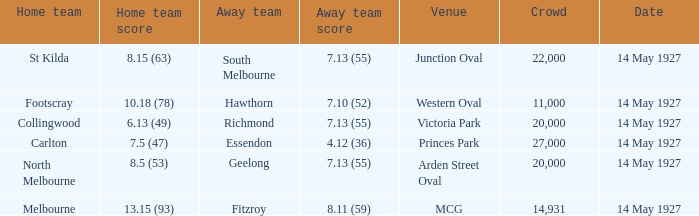Which away team had a score of 7.13 (55) against the home team North Melbourne? Geelong. 